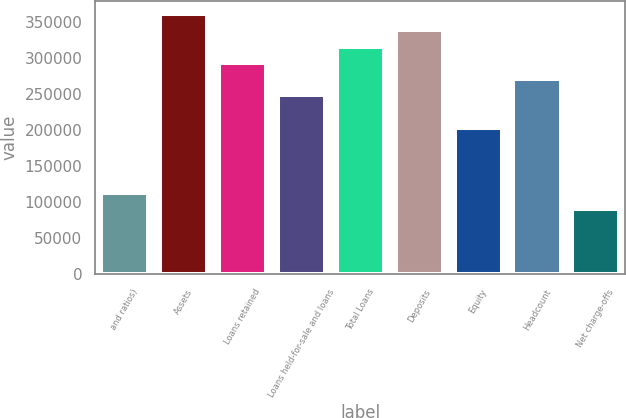<chart> <loc_0><loc_0><loc_500><loc_500><bar_chart><fcel>and ratios)<fcel>Assets<fcel>Loans retained<fcel>Loans held-for-sale and loans<fcel>Total Loans<fcel>Deposits<fcel>Equity<fcel>Headcount<fcel>Net charge-offs<nl><fcel>112954<fcel>361452<fcel>293680<fcel>248499<fcel>316271<fcel>338862<fcel>203317<fcel>271089<fcel>90363.7<nl></chart> 